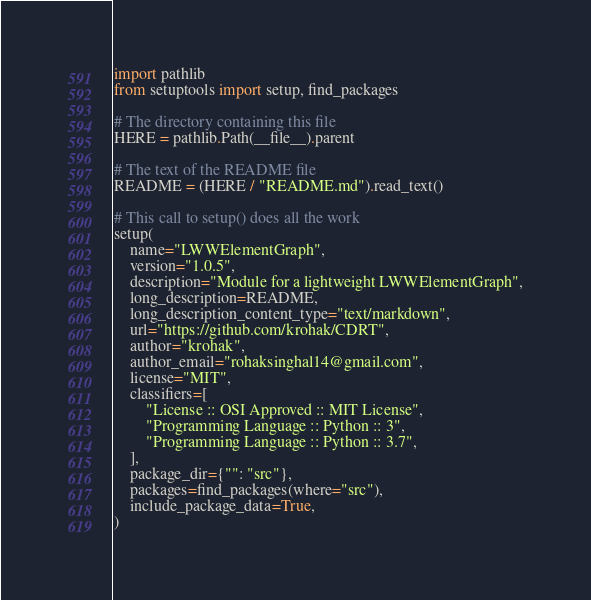<code> <loc_0><loc_0><loc_500><loc_500><_Python_>import pathlib
from setuptools import setup, find_packages

# The directory containing this file
HERE = pathlib.Path(__file__).parent

# The text of the README file
README = (HERE / "README.md").read_text()

# This call to setup() does all the work
setup(
    name="LWWElementGraph",
    version="1.0.5",
    description="Module for a lightweight LWWElementGraph",
    long_description=README,
    long_description_content_type="text/markdown",
    url="https://github.com/krohak/CDRT",
    author="krohak",
    author_email="rohaksinghal14@gmail.com",
    license="MIT",
    classifiers=[
        "License :: OSI Approved :: MIT License",
        "Programming Language :: Python :: 3",
        "Programming Language :: Python :: 3.7",
    ],
    package_dir={"": "src"},
    packages=find_packages(where="src"),
    include_package_data=True,
)</code> 